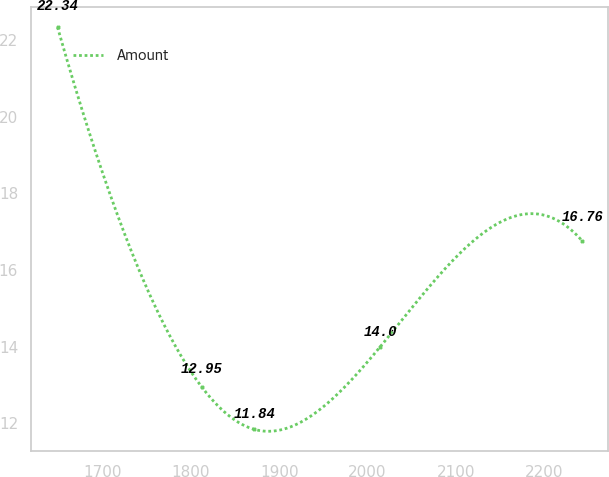Convert chart to OTSL. <chart><loc_0><loc_0><loc_500><loc_500><line_chart><ecel><fcel>Amount<nl><fcel>1648.86<fcel>22.34<nl><fcel>1812.13<fcel>12.95<nl><fcel>1871.59<fcel>11.84<nl><fcel>2014.72<fcel>14<nl><fcel>2243.41<fcel>16.76<nl></chart> 